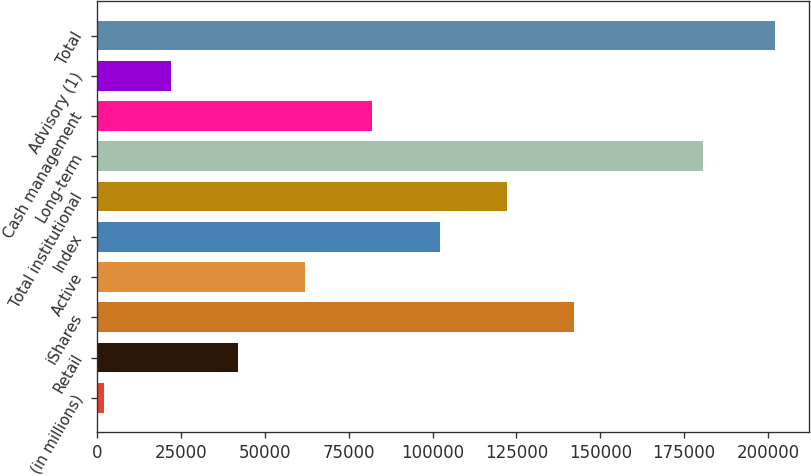Convert chart to OTSL. <chart><loc_0><loc_0><loc_500><loc_500><bar_chart><fcel>(in millions)<fcel>Retail<fcel>iShares<fcel>Active<fcel>Index<fcel>Total institutional<fcel>Long-term<fcel>Cash management<fcel>Advisory (1)<fcel>Total<nl><fcel>2016<fcel>42051<fcel>142138<fcel>62068.5<fcel>102104<fcel>122121<fcel>180564<fcel>82086<fcel>22033.5<fcel>202191<nl></chart> 